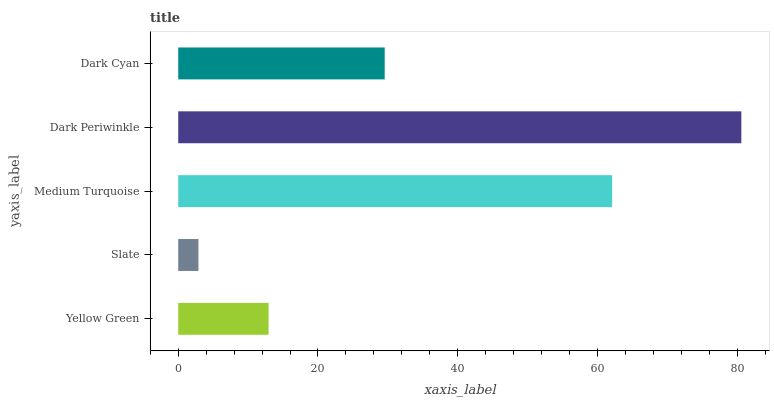Is Slate the minimum?
Answer yes or no. Yes. Is Dark Periwinkle the maximum?
Answer yes or no. Yes. Is Medium Turquoise the minimum?
Answer yes or no. No. Is Medium Turquoise the maximum?
Answer yes or no. No. Is Medium Turquoise greater than Slate?
Answer yes or no. Yes. Is Slate less than Medium Turquoise?
Answer yes or no. Yes. Is Slate greater than Medium Turquoise?
Answer yes or no. No. Is Medium Turquoise less than Slate?
Answer yes or no. No. Is Dark Cyan the high median?
Answer yes or no. Yes. Is Dark Cyan the low median?
Answer yes or no. Yes. Is Dark Periwinkle the high median?
Answer yes or no. No. Is Yellow Green the low median?
Answer yes or no. No. 